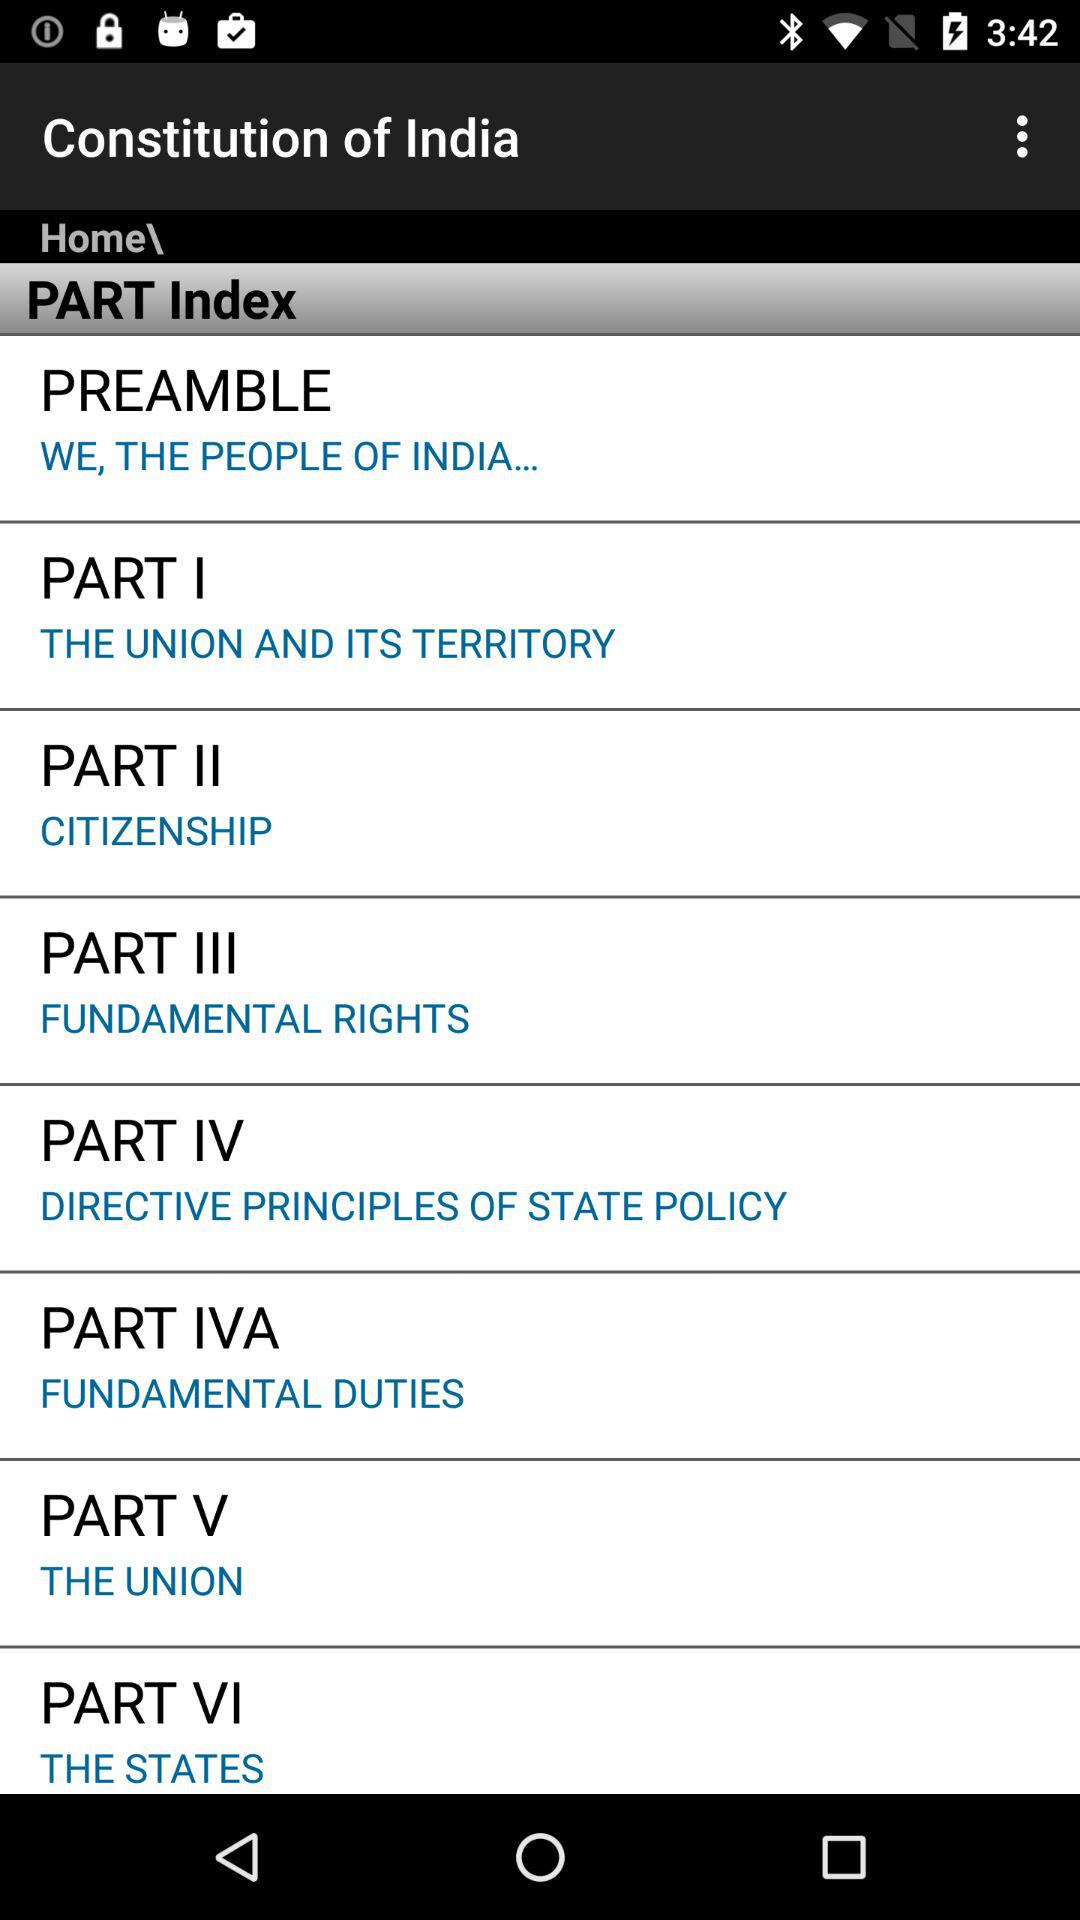Which part of India's constitution is represented by "THE UNION"? "THE UNION" represents Part V of India's constitution. 